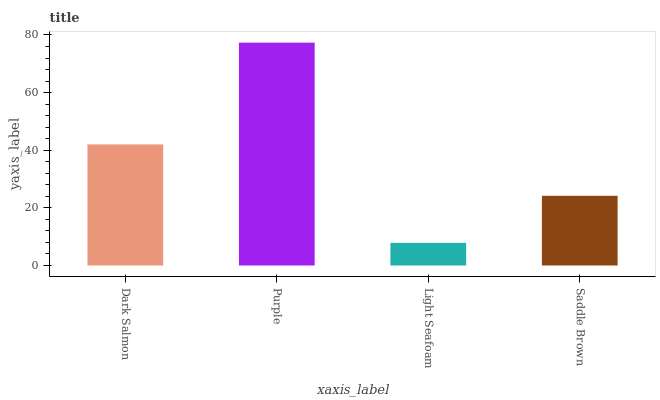Is Light Seafoam the minimum?
Answer yes or no. Yes. Is Purple the maximum?
Answer yes or no. Yes. Is Purple the minimum?
Answer yes or no. No. Is Light Seafoam the maximum?
Answer yes or no. No. Is Purple greater than Light Seafoam?
Answer yes or no. Yes. Is Light Seafoam less than Purple?
Answer yes or no. Yes. Is Light Seafoam greater than Purple?
Answer yes or no. No. Is Purple less than Light Seafoam?
Answer yes or no. No. Is Dark Salmon the high median?
Answer yes or no. Yes. Is Saddle Brown the low median?
Answer yes or no. Yes. Is Purple the high median?
Answer yes or no. No. Is Dark Salmon the low median?
Answer yes or no. No. 